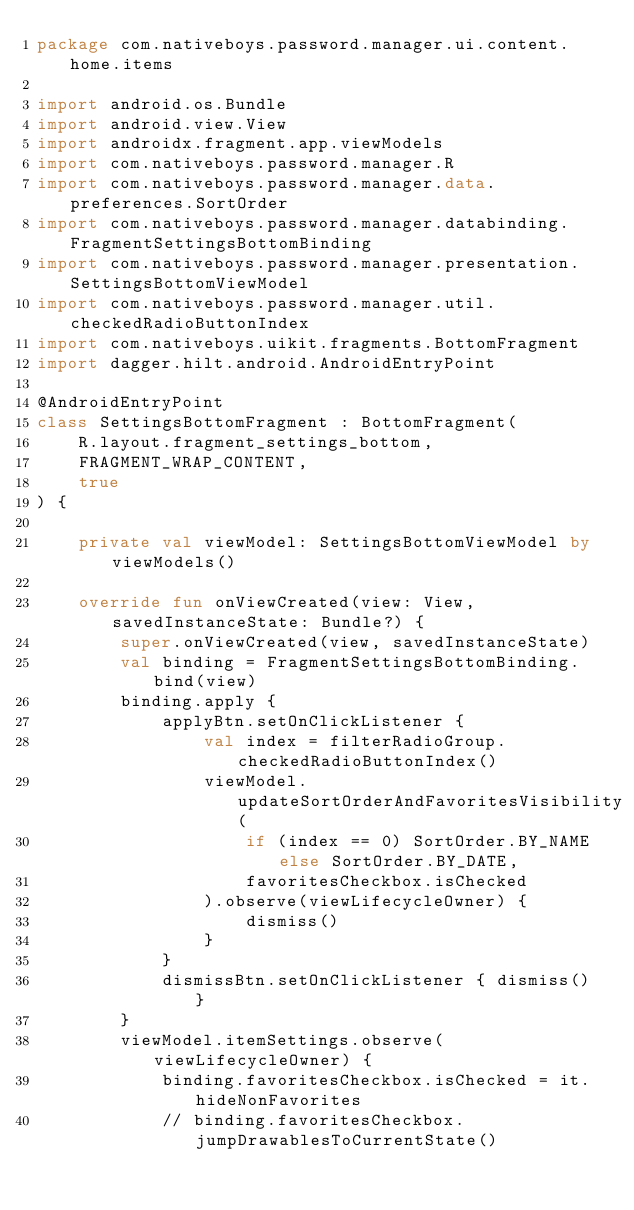Convert code to text. <code><loc_0><loc_0><loc_500><loc_500><_Kotlin_>package com.nativeboys.password.manager.ui.content.home.items

import android.os.Bundle
import android.view.View
import androidx.fragment.app.viewModels
import com.nativeboys.password.manager.R
import com.nativeboys.password.manager.data.preferences.SortOrder
import com.nativeboys.password.manager.databinding.FragmentSettingsBottomBinding
import com.nativeboys.password.manager.presentation.SettingsBottomViewModel
import com.nativeboys.password.manager.util.checkedRadioButtonIndex
import com.nativeboys.uikit.fragments.BottomFragment
import dagger.hilt.android.AndroidEntryPoint

@AndroidEntryPoint
class SettingsBottomFragment : BottomFragment(
    R.layout.fragment_settings_bottom,
    FRAGMENT_WRAP_CONTENT,
    true
) {

    private val viewModel: SettingsBottomViewModel by viewModels()

    override fun onViewCreated(view: View, savedInstanceState: Bundle?) {
        super.onViewCreated(view, savedInstanceState)
        val binding = FragmentSettingsBottomBinding.bind(view)
        binding.apply {
            applyBtn.setOnClickListener {
                val index = filterRadioGroup.checkedRadioButtonIndex()
                viewModel.updateSortOrderAndFavoritesVisibility(
                    if (index == 0) SortOrder.BY_NAME else SortOrder.BY_DATE,
                    favoritesCheckbox.isChecked
                ).observe(viewLifecycleOwner) {
                    dismiss()
                }
            }
            dismissBtn.setOnClickListener { dismiss() }
        }
        viewModel.itemSettings.observe(viewLifecycleOwner) {
            binding.favoritesCheckbox.isChecked = it.hideNonFavorites
            // binding.favoritesCheckbox.jumpDrawablesToCurrentState()
</code> 